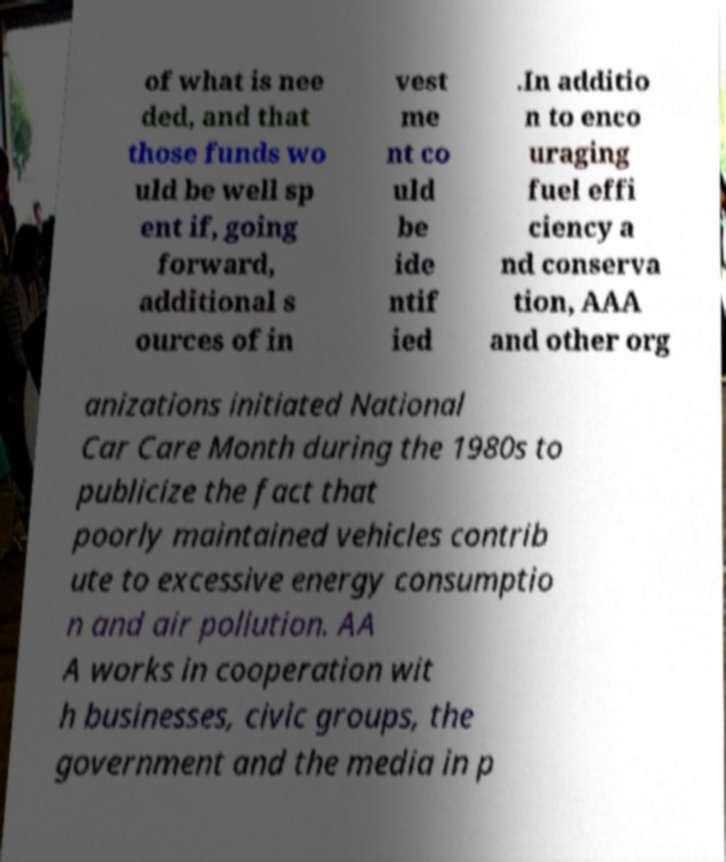Can you read and provide the text displayed in the image?This photo seems to have some interesting text. Can you extract and type it out for me? of what is nee ded, and that those funds wo uld be well sp ent if, going forward, additional s ources of in vest me nt co uld be ide ntif ied .In additio n to enco uraging fuel effi ciency a nd conserva tion, AAA and other org anizations initiated National Car Care Month during the 1980s to publicize the fact that poorly maintained vehicles contrib ute to excessive energy consumptio n and air pollution. AA A works in cooperation wit h businesses, civic groups, the government and the media in p 